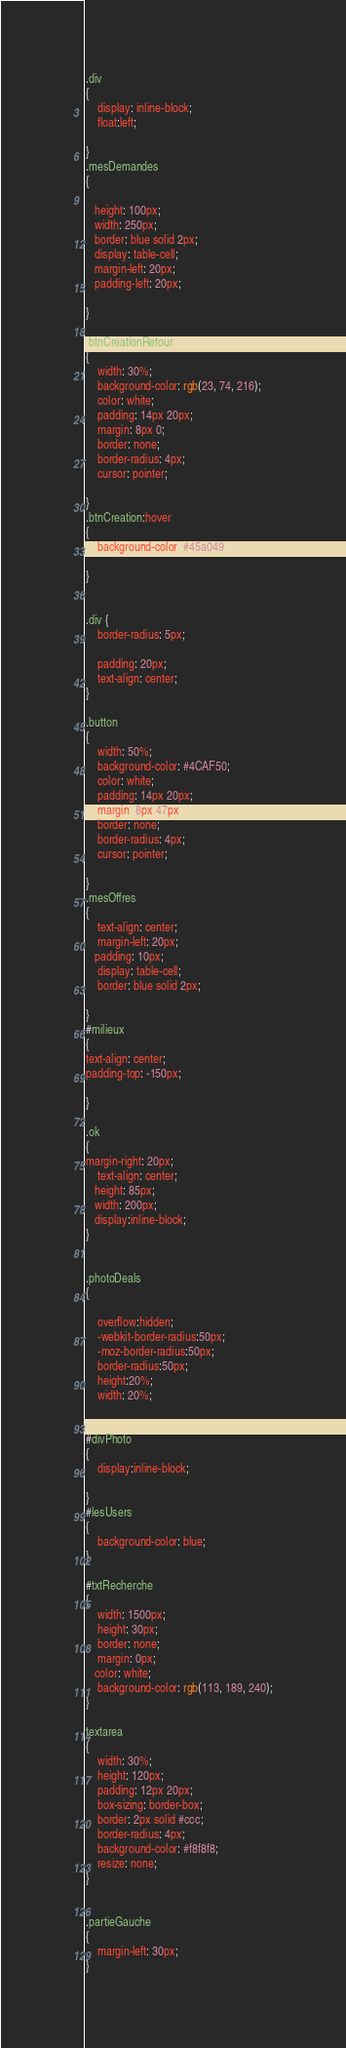<code> <loc_0><loc_0><loc_500><loc_500><_CSS_>.div
{
    display: inline-block;
    float:left;
  
}
.mesDemandes
{
   
   height: 100px;
   width: 250px;
   border: blue solid 2px;
   display: table-cell;
   margin-left: 20px;
   padding-left: 20px;
   
}

.btnCreationRetour
{
    width: 30%;
    background-color: rgb(23, 74, 216);
    color: white;
    padding: 14px 20px;
    margin: 8px 0;
    border: none;
    border-radius: 4px;
    cursor: pointer;

}
.btnCreation:hover
{
    background-color: #45a049;

}


.div {
    border-radius: 5px;
    
    padding: 20px;
    text-align: center;
}

.button
{
    width: 50%;
    background-color: #4CAF50;
    color: white;
    padding: 14px 20px;
    margin: 8px 47px;
    border: none;
    border-radius: 4px;
    cursor: pointer;

}
.mesOffres
{
    text-align: center;
    margin-left: 20px;
   padding: 10px;
    display: table-cell;
    border: blue solid 2px;

}
#milieux
{
text-align: center;
padding-top: -150px;

}

.ok
{
margin-right: 20px;
    text-align: center;
   height: 85px;
   width: 200px;
   display:inline-block;
}


.photoDeals
{

    overflow:hidden;
    -webkit-border-radius:50px;
    -moz-border-radius:50px;
    border-radius:50px;
    height:20%;
    width: 20%;
   
}
#divPhoto
{
    display:inline-block;

}
#lesUsers
{
    background-color: blue;
}

#txtRecherche
{
    width: 1500px;
    height: 30px;
    border: none;
    margin: 0px;
   color: white;
    background-color: rgb(113, 189, 240);
}

textarea 
{
    width: 30%;
    height: 120px;
    padding: 12px 20px;
    box-sizing: border-box;
    border: 2px solid #ccc;
    border-radius: 4px;
    background-color: #f8f8f8;
    resize: none;
}


.partieGauche
{
    margin-left: 30px;
}</code> 